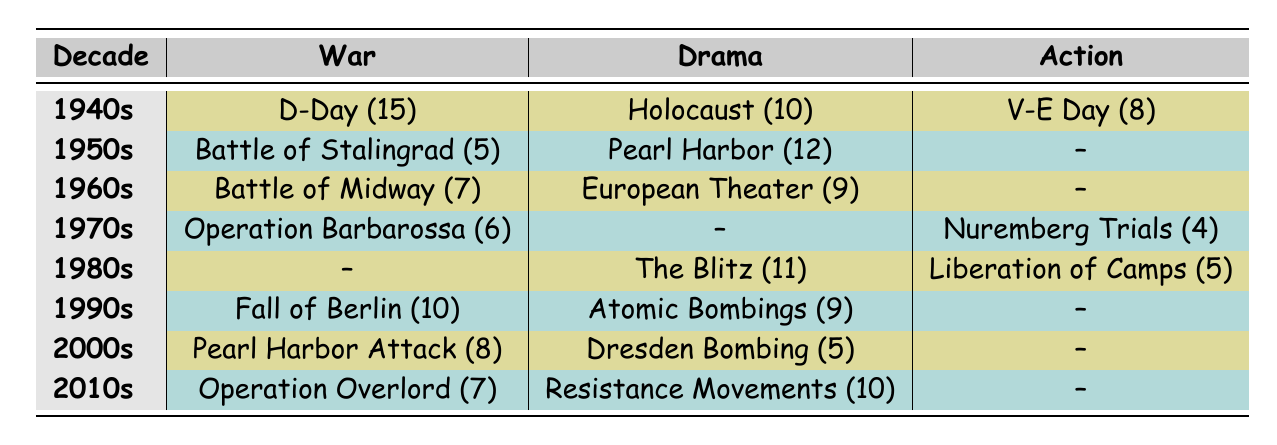What historical event had the highest frequency in the 1940s War genre? By looking at the table, we see that "D-Day" has the highest frequency with a count of 15 occurrences under the 1940s War genre.
Answer: D-Day Which decade shows the highest frequency for the Drama genre? From the table, we can extract the frequencies for the Drama genre across decades: 10 (1940s), 12 (1950s), 9 (1960s), 0 (1970s), 11 (1980s), 9 (1990s), 5 (2000s), and 10 (2010s). The highest value is 12 in the 1950s.
Answer: 1950s What is the total frequency of War events across all decades? To find the total, we add the frequencies of War events listed in the table: 15 + 5 + 7 + 6 + 0 + 10 + 8 + 7 = 58.
Answer: 58 Is it true that the 1980s had the most frequent Action events? The frequencies for Action events in the 1980s is 5, but there are no recorded Action events for the 1970s, and the highest frequency in another decade (e.g., 1940s) is only 8 for V-E Day. Thus, it is false that the 1980s had the most frequent Action events.
Answer: No How does the frequency of the Holocaust in War vs. Drama compare across the decades? In the 1940s, the frequency of the Holocaust in Drama is 10, whereas there is no War event category for the Holocaust noted. Therefore, Holocaust is only present in the Drama genre and does not compare directly across genres.
Answer: The Holocaust only appears in Drama What are the frequencies of Action events across all decades? Reviewing the table for Action entries, we find the frequencies: 8 (1940s), 0 (1950s), 0 (1960s), 4 (1970s), 5 (1980s), 0 (1990s), 0 (2000s), and 0 (2010s). Adding these gives 8 + 0 + 0 + 4 + 5 + 0 + 0 + 0 = 17.
Answer: 17 Which genre had the least frequency for events in the 2000s? We compare the frequencies for the 2000s across genres: War (8), Drama (5), and Action (0). The least is 0 for Action.
Answer: Action What is the average frequency of events for the Drama genre across all decades? First, extract Drama frequencies: 10 (1940s), 12 (1950s), 9 (1960s), 0 (1970s), 11 (1980s), 9 (1990s), 5 (2000s), 10 (2010s). The sum is 10 + 12 + 9 + 0 + 11 + 9 + 5 + 10 = 66. There are 8 entries, so the average is 66 / 8 = 8.25.
Answer: 8.25 